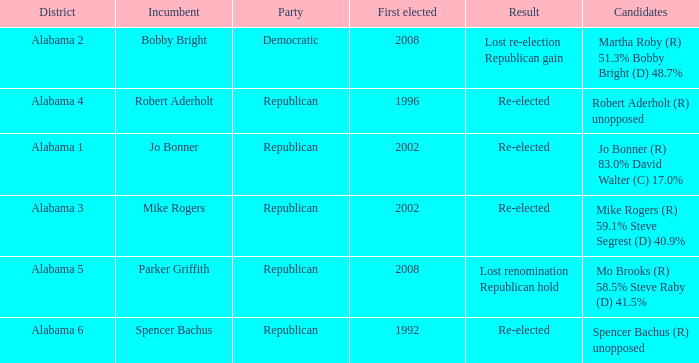Name the incumbent for lost renomination republican hold Parker Griffith. 